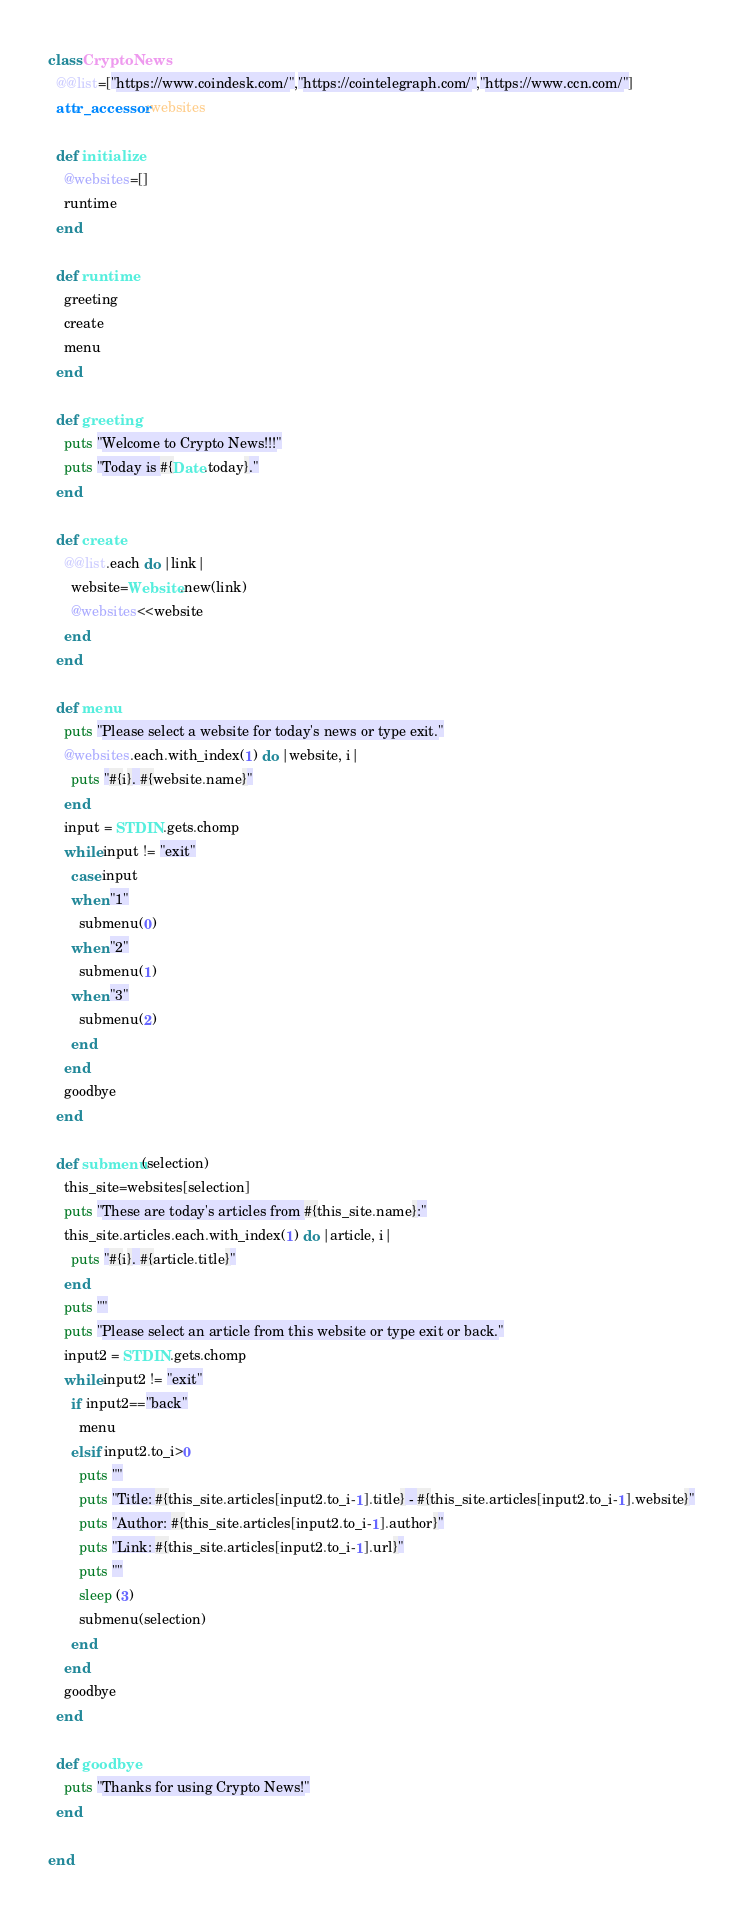<code> <loc_0><loc_0><loc_500><loc_500><_Ruby_>class CryptoNews
  @@list=["https://www.coindesk.com/","https://cointelegraph.com/","https://www.ccn.com/"]
  attr_accessor :websites

  def initialize
    @websites=[]
    runtime
  end

  def runtime
    greeting
    create
    menu
  end

  def greeting
    puts "Welcome to Crypto News!!!"
    puts "Today is #{Date.today}."
  end

  def create
    @@list.each do |link|
      website=Website.new(link)
      @websites<<website
    end
  end

  def menu
    puts "Please select a website for today's news or type exit."
    @websites.each.with_index(1) do |website, i|
      puts "#{i}. #{website.name}"
    end
    input = STDIN.gets.chomp
    while input != "exit"
      case input
      when "1"
        submenu(0)
      when "2"
        submenu(1)
      when "3"
        submenu(2)
      end
    end
    goodbye
  end

  def submenu(selection)
    this_site=websites[selection]
    puts "These are today's articles from #{this_site.name}:"
    this_site.articles.each.with_index(1) do |article, i|
      puts "#{i}. #{article.title}"
    end
    puts ""
    puts "Please select an article from this website or type exit or back."
    input2 = STDIN.gets.chomp
    while input2 != "exit"
      if input2=="back"
        menu
      elsif input2.to_i>0
        puts ""
        puts "Title: #{this_site.articles[input2.to_i-1].title} - #{this_site.articles[input2.to_i-1].website}"
        puts "Author: #{this_site.articles[input2.to_i-1].author}"
        puts "Link: #{this_site.articles[input2.to_i-1].url}"
        puts ""
        sleep (3)
        submenu(selection)
      end
    end
    goodbye
  end

  def goodbye
    puts "Thanks for using Crypto News!"
  end

end
</code> 